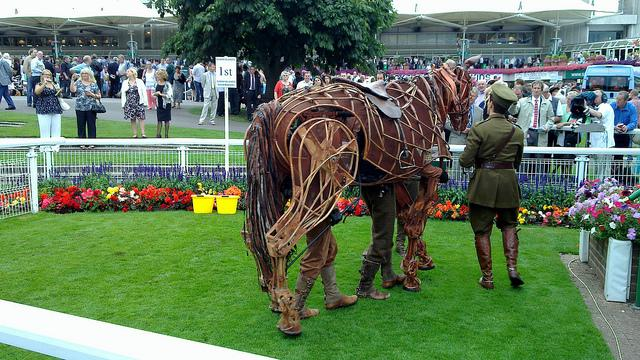What is inside of the horse sculpture?

Choices:
A) dogs
B) fish
C) food
D) humans humans 